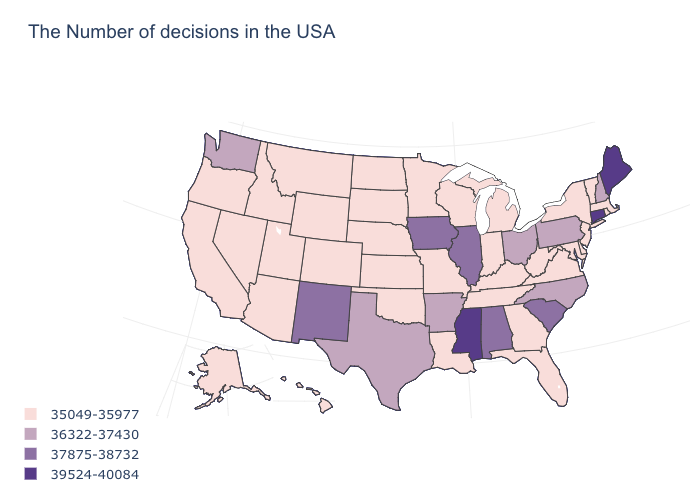Does Maine have the highest value in the USA?
Concise answer only. Yes. What is the value of Alaska?
Keep it brief. 35049-35977. Which states have the lowest value in the South?
Answer briefly. Delaware, Maryland, Virginia, West Virginia, Florida, Georgia, Kentucky, Tennessee, Louisiana, Oklahoma. Which states have the lowest value in the USA?
Concise answer only. Massachusetts, Rhode Island, Vermont, New York, New Jersey, Delaware, Maryland, Virginia, West Virginia, Florida, Georgia, Michigan, Kentucky, Indiana, Tennessee, Wisconsin, Louisiana, Missouri, Minnesota, Kansas, Nebraska, Oklahoma, South Dakota, North Dakota, Wyoming, Colorado, Utah, Montana, Arizona, Idaho, Nevada, California, Oregon, Alaska, Hawaii. Name the states that have a value in the range 35049-35977?
Short answer required. Massachusetts, Rhode Island, Vermont, New York, New Jersey, Delaware, Maryland, Virginia, West Virginia, Florida, Georgia, Michigan, Kentucky, Indiana, Tennessee, Wisconsin, Louisiana, Missouri, Minnesota, Kansas, Nebraska, Oklahoma, South Dakota, North Dakota, Wyoming, Colorado, Utah, Montana, Arizona, Idaho, Nevada, California, Oregon, Alaska, Hawaii. Among the states that border Tennessee , does Virginia have the highest value?
Write a very short answer. No. Which states hav the highest value in the West?
Give a very brief answer. New Mexico. Name the states that have a value in the range 36322-37430?
Be succinct. New Hampshire, Pennsylvania, North Carolina, Ohio, Arkansas, Texas, Washington. Among the states that border Florida , which have the highest value?
Write a very short answer. Alabama. What is the value of New Jersey?
Answer briefly. 35049-35977. What is the lowest value in the USA?
Write a very short answer. 35049-35977. Is the legend a continuous bar?
Be succinct. No. What is the value of Kansas?
Give a very brief answer. 35049-35977. Which states have the highest value in the USA?
Quick response, please. Maine, Connecticut, Mississippi. What is the highest value in the Northeast ?
Answer briefly. 39524-40084. 